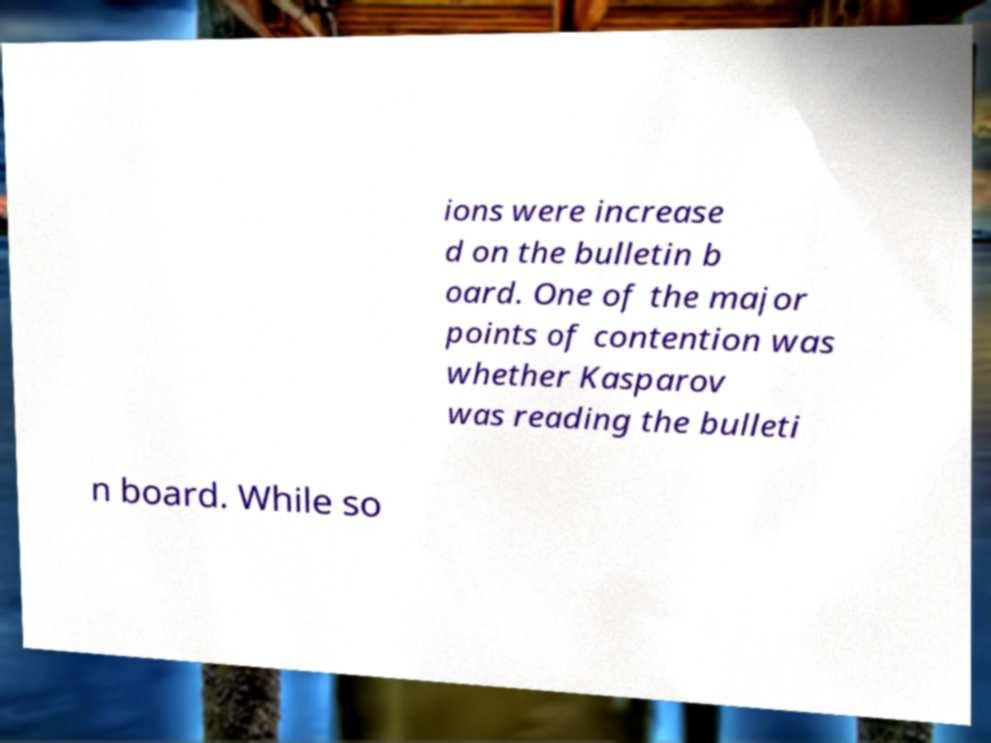Could you assist in decoding the text presented in this image and type it out clearly? ions were increase d on the bulletin b oard. One of the major points of contention was whether Kasparov was reading the bulleti n board. While so 